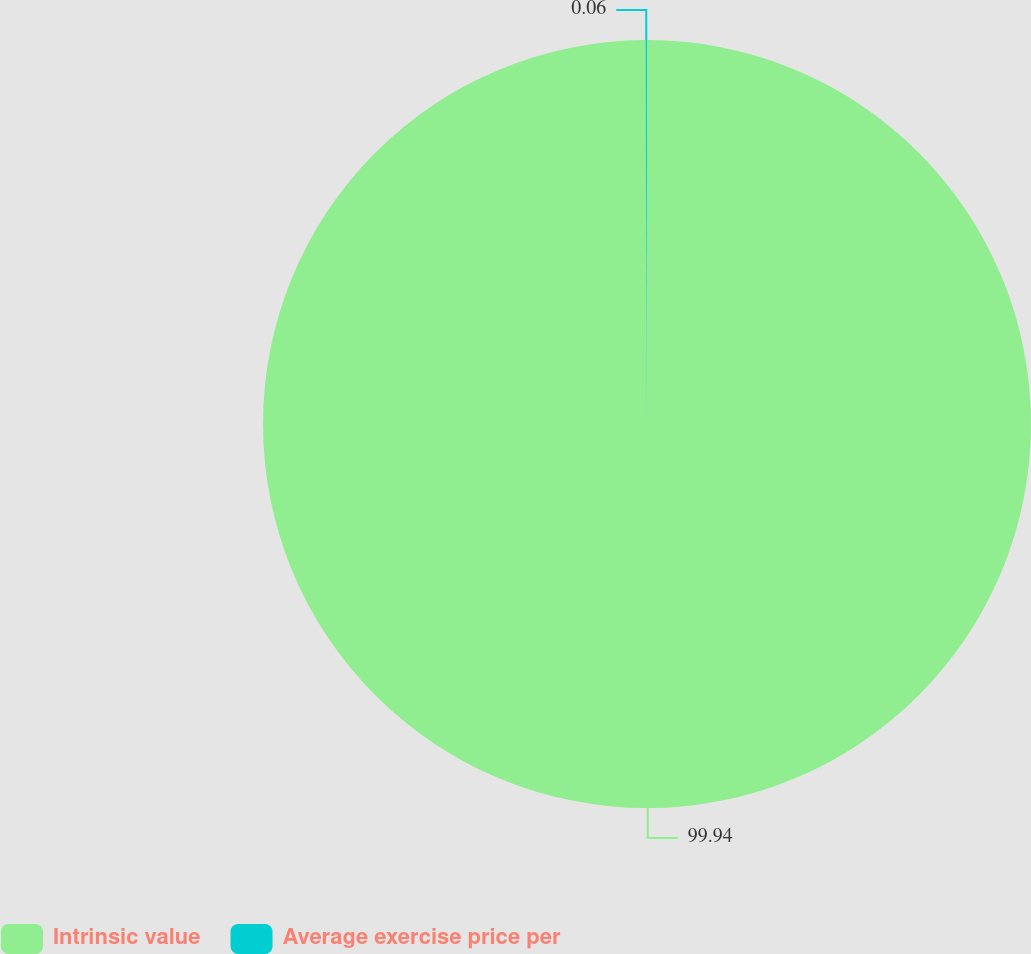<chart> <loc_0><loc_0><loc_500><loc_500><pie_chart><fcel>Intrinsic value<fcel>Average exercise price per<nl><fcel>99.94%<fcel>0.06%<nl></chart> 